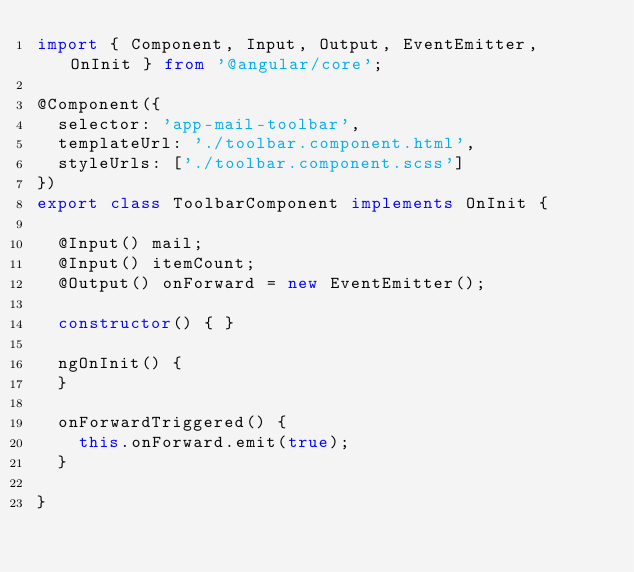Convert code to text. <code><loc_0><loc_0><loc_500><loc_500><_TypeScript_>import { Component, Input, Output, EventEmitter, OnInit } from '@angular/core';

@Component({
  selector: 'app-mail-toolbar',
  templateUrl: './toolbar.component.html',
  styleUrls: ['./toolbar.component.scss']
})
export class ToolbarComponent implements OnInit {

  @Input() mail;
  @Input() itemCount;
  @Output() onForward = new EventEmitter();

  constructor() { }

  ngOnInit() {
  }

  onForwardTriggered() {
    this.onForward.emit(true);
  }

}
</code> 